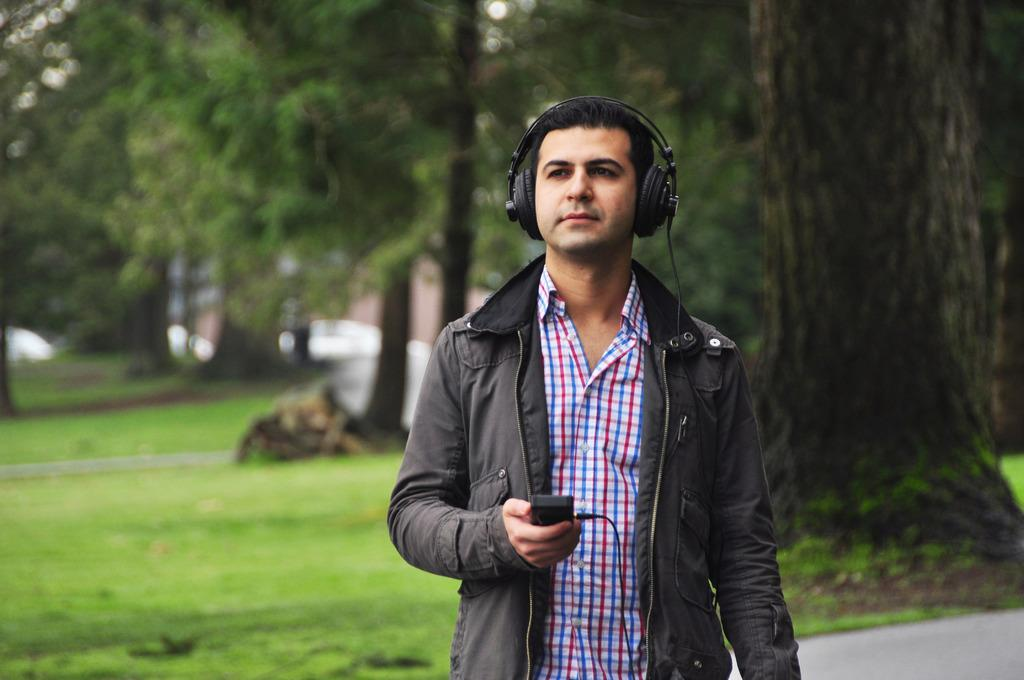What can be seen in the image related to a person? There is a person in the image. What is the person wearing in the image? The person is wearing headphones. What is the person holding in the image? The person is holding an object. What type of surface is visible in the image? There is ground visible in the image. What type of vegetation can be seen in the image? There is grass and trees in the image. What type of insurance policy does the frog in the image have? There is no frog present in the image, so it is not possible to determine any insurance policy. 